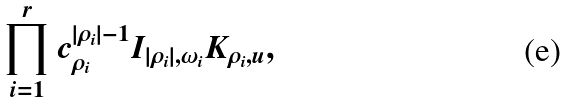Convert formula to latex. <formula><loc_0><loc_0><loc_500><loc_500>\prod _ { i = 1 } ^ { r } c _ { \rho _ { i } } ^ { | \rho _ { i } | - 1 } I _ { | \rho _ { i } | , \omega _ { i } } K _ { \rho _ { i } , u } ,</formula> 